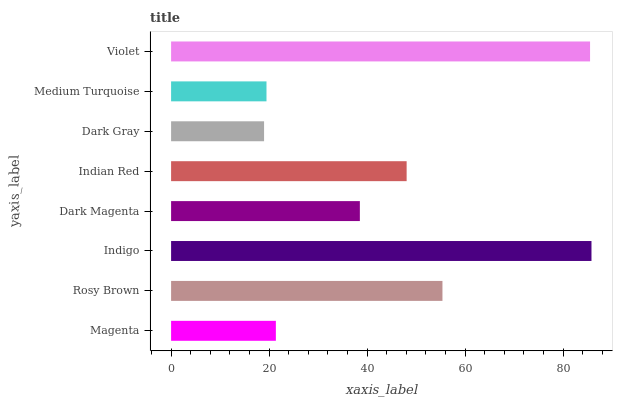Is Dark Gray the minimum?
Answer yes or no. Yes. Is Indigo the maximum?
Answer yes or no. Yes. Is Rosy Brown the minimum?
Answer yes or no. No. Is Rosy Brown the maximum?
Answer yes or no. No. Is Rosy Brown greater than Magenta?
Answer yes or no. Yes. Is Magenta less than Rosy Brown?
Answer yes or no. Yes. Is Magenta greater than Rosy Brown?
Answer yes or no. No. Is Rosy Brown less than Magenta?
Answer yes or no. No. Is Indian Red the high median?
Answer yes or no. Yes. Is Dark Magenta the low median?
Answer yes or no. Yes. Is Medium Turquoise the high median?
Answer yes or no. No. Is Violet the low median?
Answer yes or no. No. 